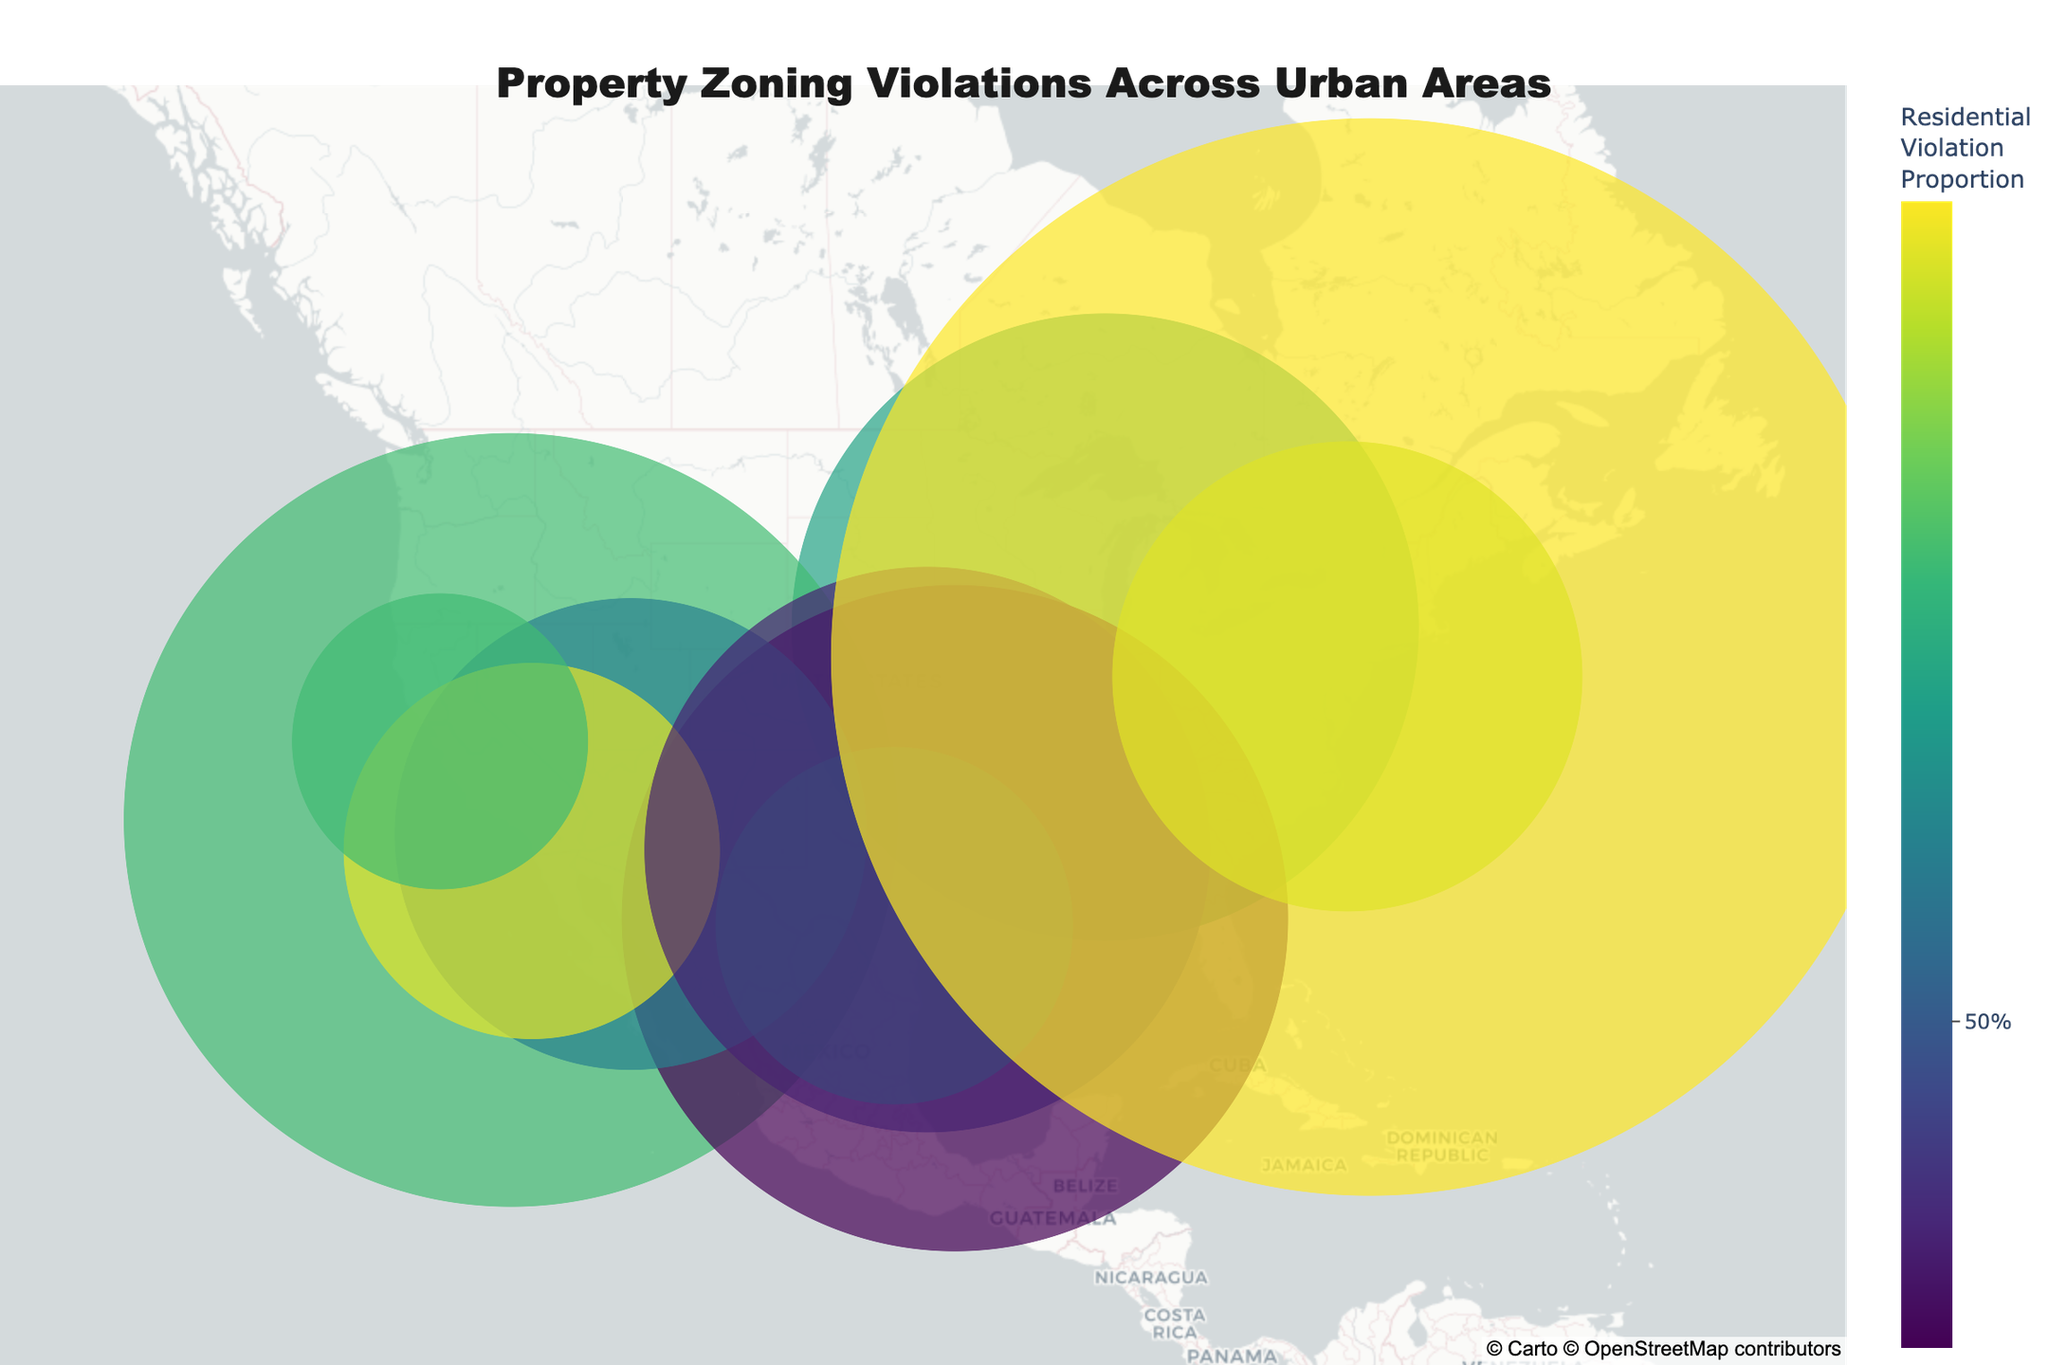What's the title of the plot? The title is usually displayed prominently at the top. In this case, the title of the plot is "Property Zoning Violations Across Urban Areas," as indicated in the code.
Answer: Property Zoning Violations Across Urban Areas What does the different colors on the markers represent? The colors represent the proportion of residential violations relative to the total violations. A colorscale is used where 0% would be pure commercial violations and 100% would be pure residential violations.
Answer: Proportion of residential violations Which city has the highest number of residential violations? By looking at the data associated with each city and observing the hover information, New York City has the highest number of residential violations, with 387 violations.
Answer: New York City How is the marker size determined on the plot? The marker size is determined by the total number of violations (residential + commercial) in each city. For example, the size of the marker for New York City would be based on 387 + 245 = 632 violations.
Answer: Total number of violations What is the most common violation type in Chicago? By hovering over the marker for Chicago, the text information will show that the most common violation type is "Building code violations."
Answer: Building code violations Which city has a higher proportion of commercial violations: Dallas or Houston? Examine the colors and hover information for each city. Dallas has a higher proportion of commercial violations (176 out of a total of 332), compared to Houston's 213 out of a total of 391.
Answer: Dallas What's the sum of total violations in Los Angeles? The total violations are the sum of residential violations and commercial violations. For Los Angeles, it is 256 + 198 = 454.
Answer: 454 Which city has the most evenly distributed residential and commercial violations? By looking at the ratio of residential to commercial violations and the colors of the markers, Phoenix has almost evenly distributed violations with 145 residential and 132 commercial.
Answer: Phoenix Is there any city where the most common type of violation is related to occupancy limits? Reviewing the text information for each city will show that Phoenix has "Occupancy limit breaches" as its most common violation type.
Answer: Phoenix Which city has the lowest number of commercial violations? By examining the hover information, San Jose has the lowest number of commercial violations with only 76.
Answer: San Jose 